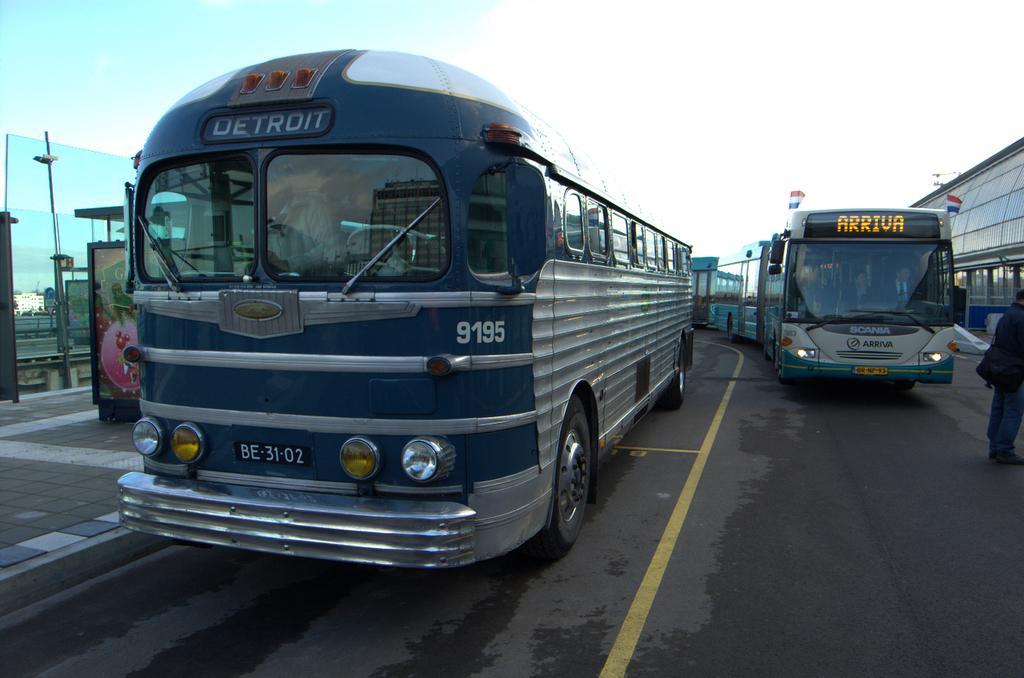Can you describe this image briefly? This image is clicked on the road. There are many buses parked on the road. At the bottom, there is road. To the left, there is a pavement. To the right, there is a man standing. 